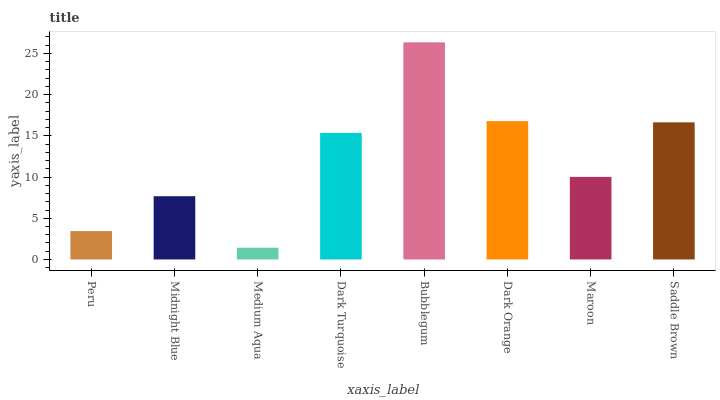Is Midnight Blue the minimum?
Answer yes or no. No. Is Midnight Blue the maximum?
Answer yes or no. No. Is Midnight Blue greater than Peru?
Answer yes or no. Yes. Is Peru less than Midnight Blue?
Answer yes or no. Yes. Is Peru greater than Midnight Blue?
Answer yes or no. No. Is Midnight Blue less than Peru?
Answer yes or no. No. Is Dark Turquoise the high median?
Answer yes or no. Yes. Is Maroon the low median?
Answer yes or no. Yes. Is Maroon the high median?
Answer yes or no. No. Is Saddle Brown the low median?
Answer yes or no. No. 